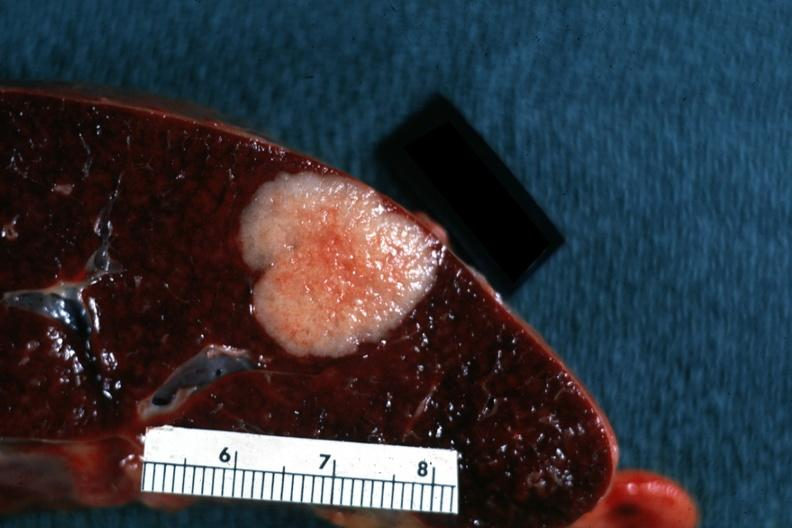s hemisection of nose present?
Answer the question using a single word or phrase. No 